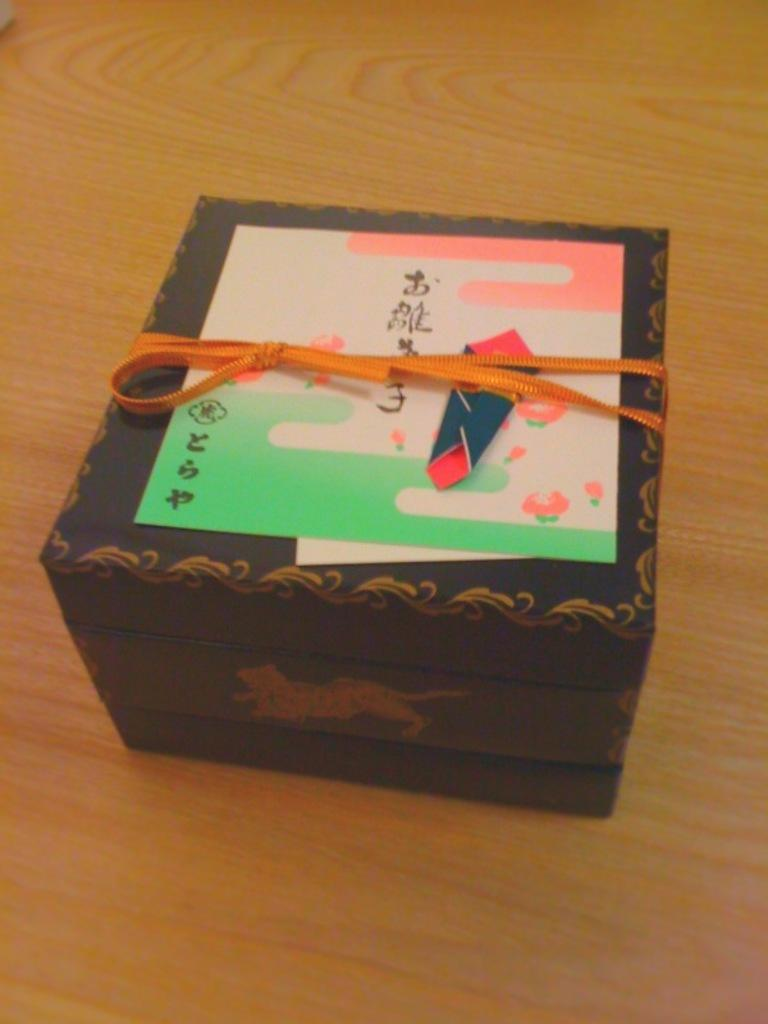<image>
Share a concise interpretation of the image provided. A small box is tied up with a ribbon and has a card with Asian writing on it. 